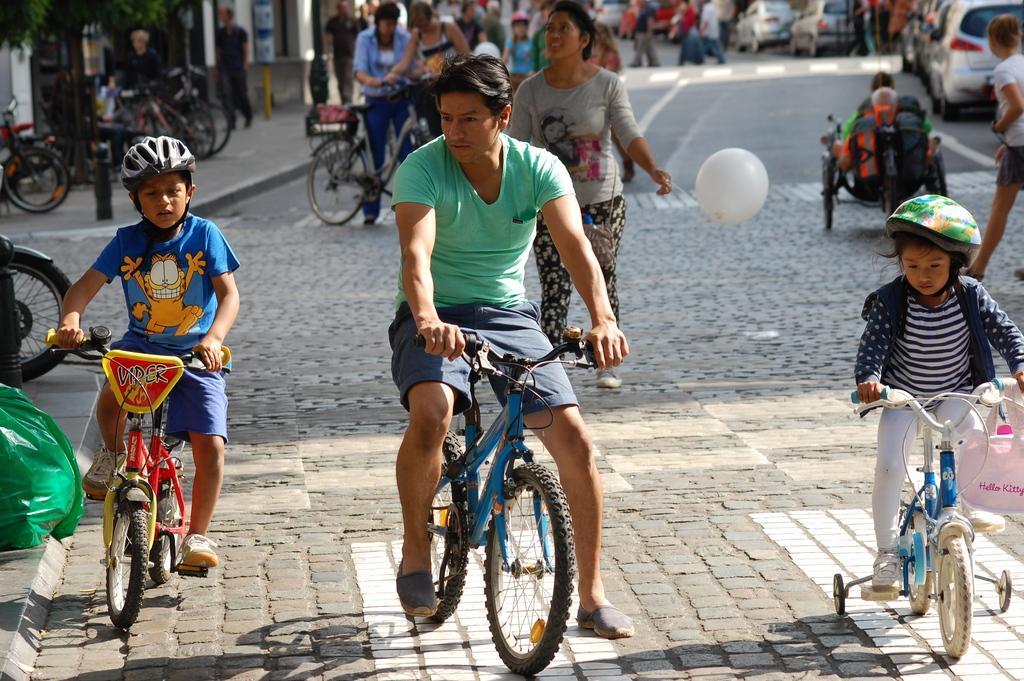Could you give a brief overview of what you see in this image? In this image I can see the group of people and the car on the road. Among them some people are riding the bicycle and one person is holding the balloon. 